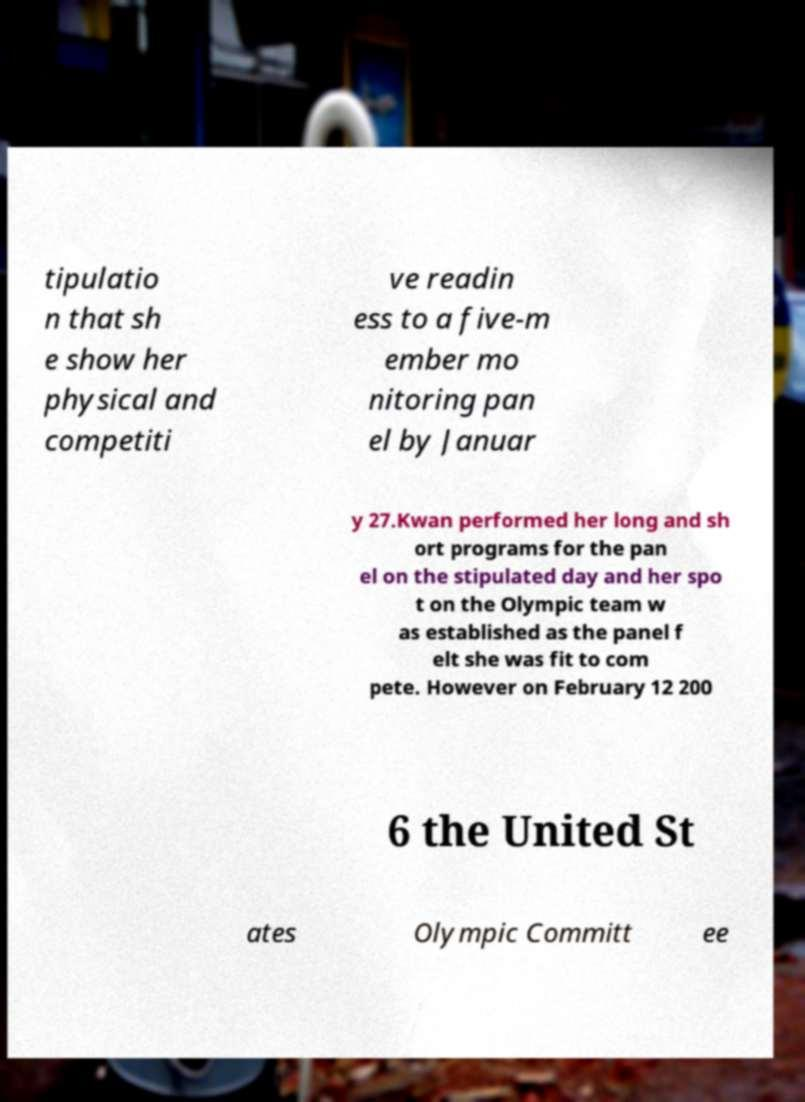There's text embedded in this image that I need extracted. Can you transcribe it verbatim? tipulatio n that sh e show her physical and competiti ve readin ess to a five-m ember mo nitoring pan el by Januar y 27.Kwan performed her long and sh ort programs for the pan el on the stipulated day and her spo t on the Olympic team w as established as the panel f elt she was fit to com pete. However on February 12 200 6 the United St ates Olympic Committ ee 